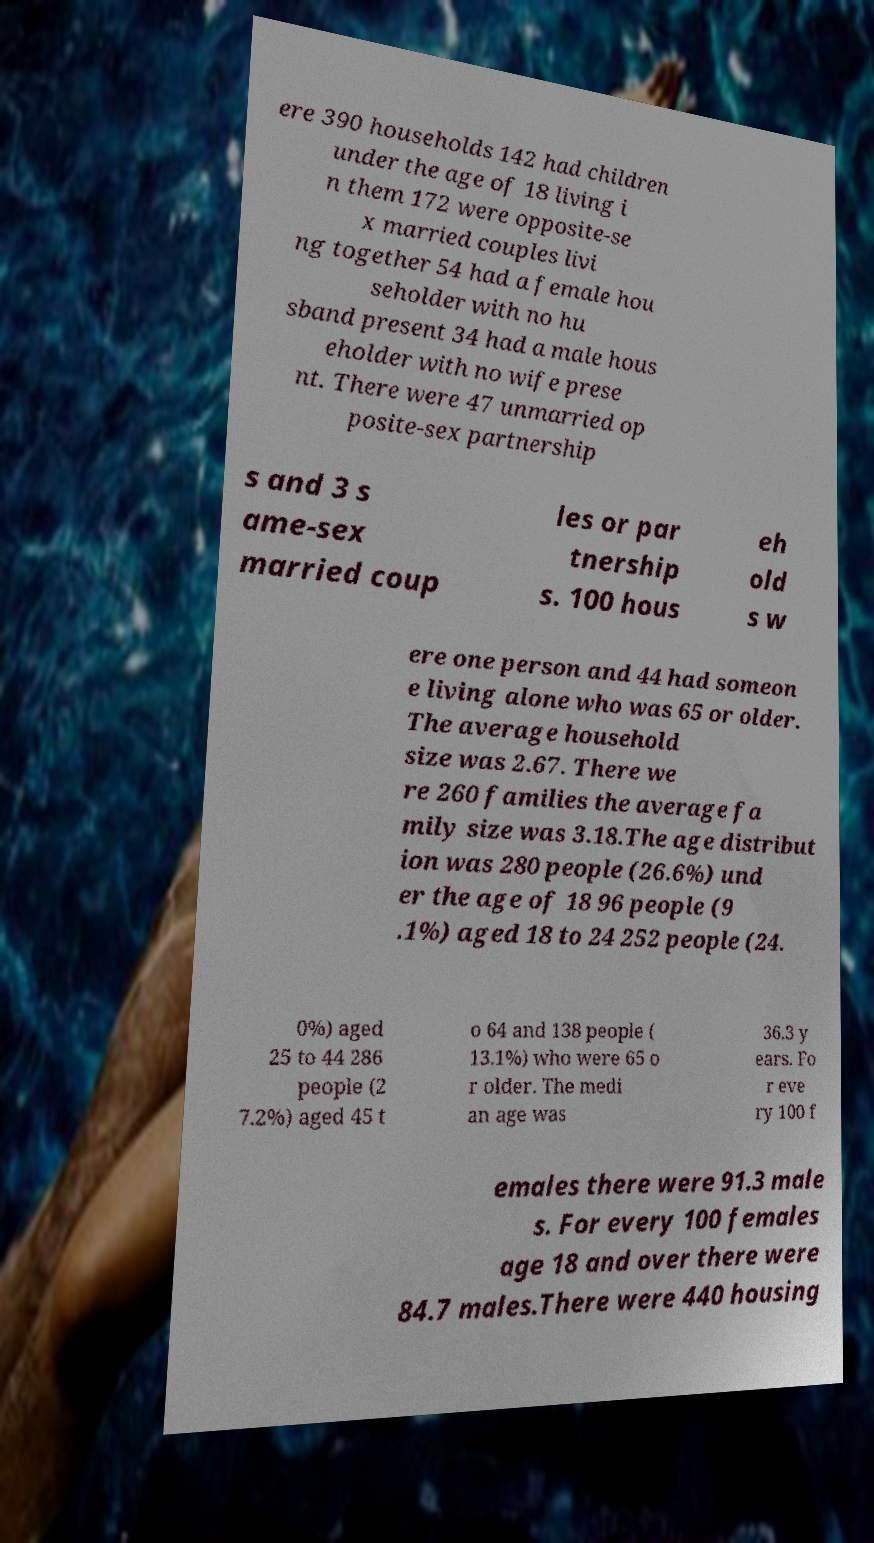For documentation purposes, I need the text within this image transcribed. Could you provide that? ere 390 households 142 had children under the age of 18 living i n them 172 were opposite-se x married couples livi ng together 54 had a female hou seholder with no hu sband present 34 had a male hous eholder with no wife prese nt. There were 47 unmarried op posite-sex partnership s and 3 s ame-sex married coup les or par tnership s. 100 hous eh old s w ere one person and 44 had someon e living alone who was 65 or older. The average household size was 2.67. There we re 260 families the average fa mily size was 3.18.The age distribut ion was 280 people (26.6%) und er the age of 18 96 people (9 .1%) aged 18 to 24 252 people (24. 0%) aged 25 to 44 286 people (2 7.2%) aged 45 t o 64 and 138 people ( 13.1%) who were 65 o r older. The medi an age was 36.3 y ears. Fo r eve ry 100 f emales there were 91.3 male s. For every 100 females age 18 and over there were 84.7 males.There were 440 housing 